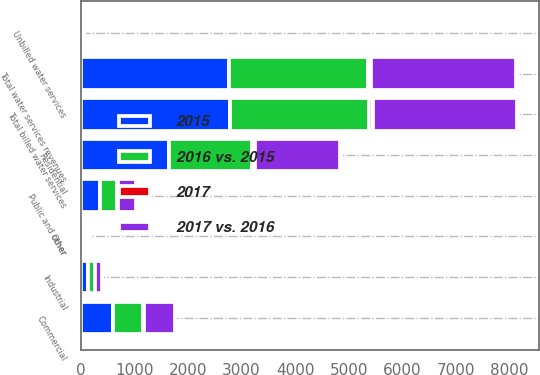Convert chart to OTSL. <chart><loc_0><loc_0><loc_500><loc_500><stacked_bar_chart><ecel><fcel>Residential<fcel>Commercial<fcel>Industrial<fcel>Public and other<fcel>Other<fcel>Total billed water services<fcel>Unbilled water services<fcel>Total water services revenues<nl><fcel>2015<fcel>1654<fcel>603<fcel>137<fcel>351<fcel>31<fcel>2776<fcel>11<fcel>2765<nl><fcel>2017 vs. 2016<fcel>1592<fcel>580<fcel>134<fcel>338<fcel>53<fcel>2697<fcel>13<fcel>2710<nl><fcel>2016 vs. 2015<fcel>1536<fcel>559<fcel>130<fcel>331<fcel>39<fcel>2595<fcel>3<fcel>2592<nl><fcel>2017<fcel>62<fcel>23<fcel>3<fcel>13<fcel>22<fcel>79<fcel>24<fcel>55<nl></chart> 